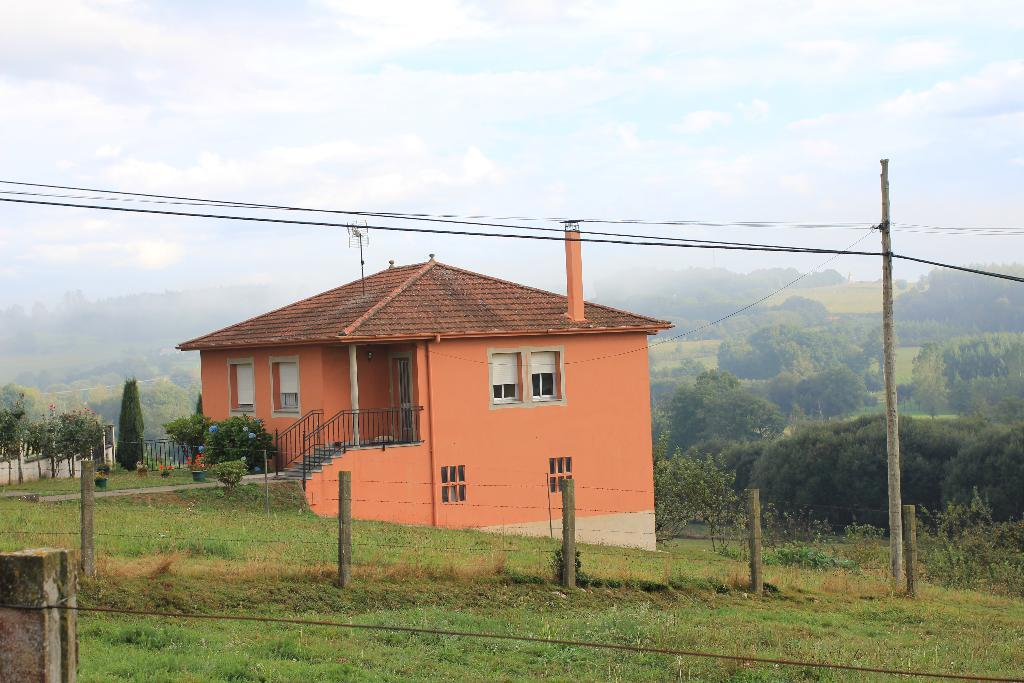What type of structure is visible in the image? There is a building in the image. What feature can be seen on the building? The building has windows. What type of vegetation is present in the image? There is grass, a plant, and trees in the image. What architectural element can be seen in the image? There is a pole, a fence, and stairs in the image. What is the condition of the sky in the image? The sky is cloudy in the image. What type of house is visible in the image? There is no house present in the image; it features a building. What type of need can be seen in the image? There is no need present in the image; it is a photograph of a building and its surroundings. 